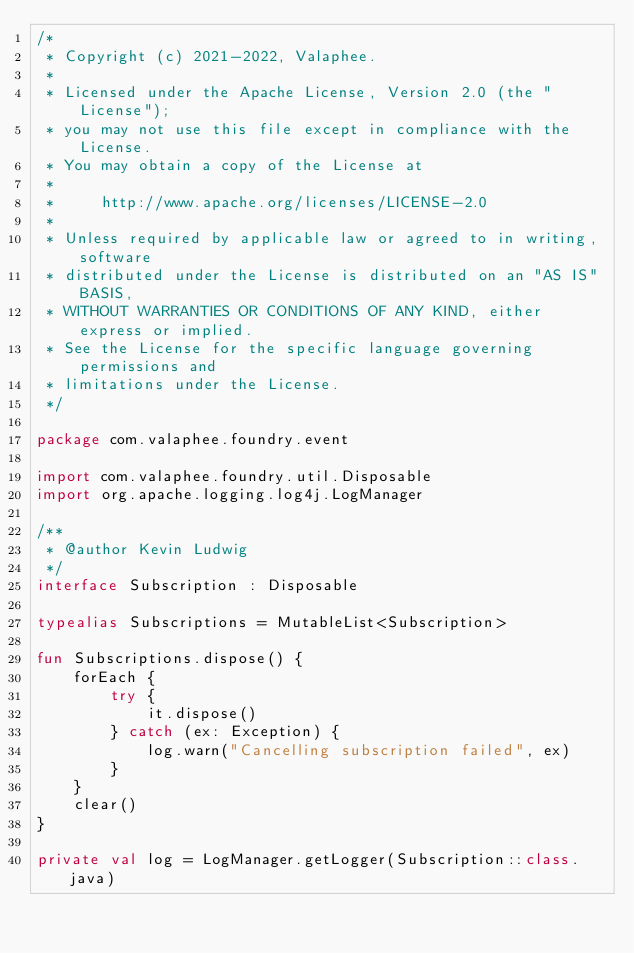Convert code to text. <code><loc_0><loc_0><loc_500><loc_500><_Kotlin_>/*
 * Copyright (c) 2021-2022, Valaphee.
 *
 * Licensed under the Apache License, Version 2.0 (the "License");
 * you may not use this file except in compliance with the License.
 * You may obtain a copy of the License at
 *
 *     http://www.apache.org/licenses/LICENSE-2.0
 *
 * Unless required by applicable law or agreed to in writing, software
 * distributed under the License is distributed on an "AS IS" BASIS,
 * WITHOUT WARRANTIES OR CONDITIONS OF ANY KIND, either express or implied.
 * See the License for the specific language governing permissions and
 * limitations under the License.
 */

package com.valaphee.foundry.event

import com.valaphee.foundry.util.Disposable
import org.apache.logging.log4j.LogManager

/**
 * @author Kevin Ludwig
 */
interface Subscription : Disposable

typealias Subscriptions = MutableList<Subscription>

fun Subscriptions.dispose() {
    forEach {
        try {
            it.dispose()
        } catch (ex: Exception) {
            log.warn("Cancelling subscription failed", ex)
        }
    }
    clear()
}

private val log = LogManager.getLogger(Subscription::class.java)
</code> 